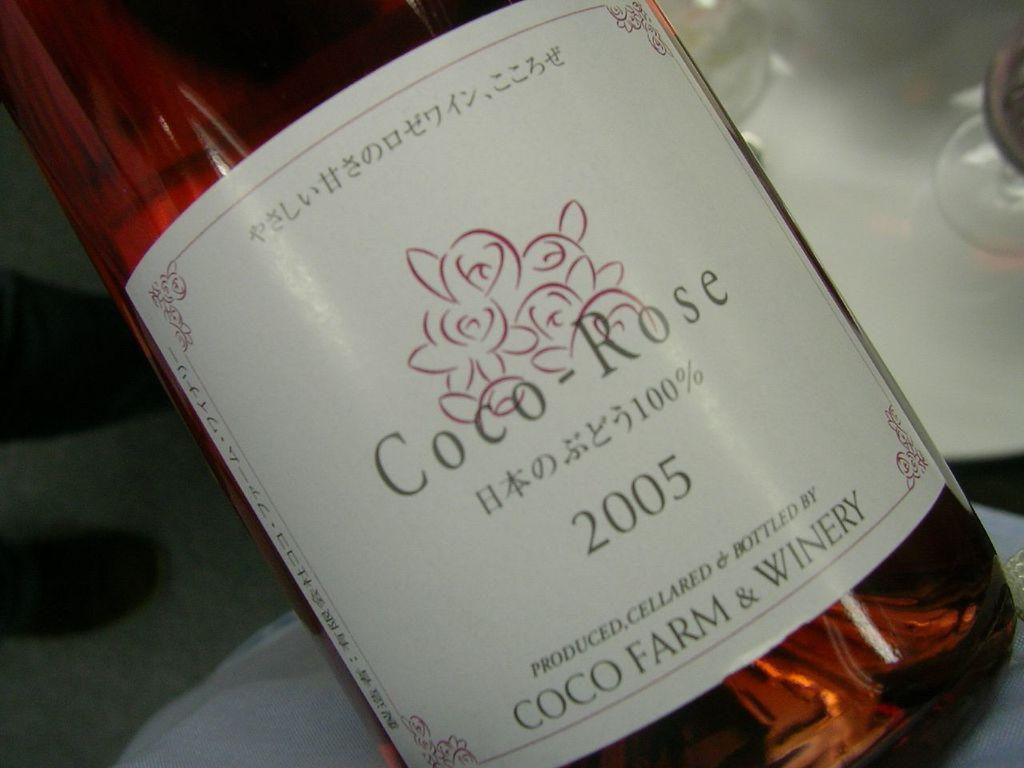<image>
Provide a brief description of the given image. bottle of 2005 coco-rose wine that also has some asian writing on the label 